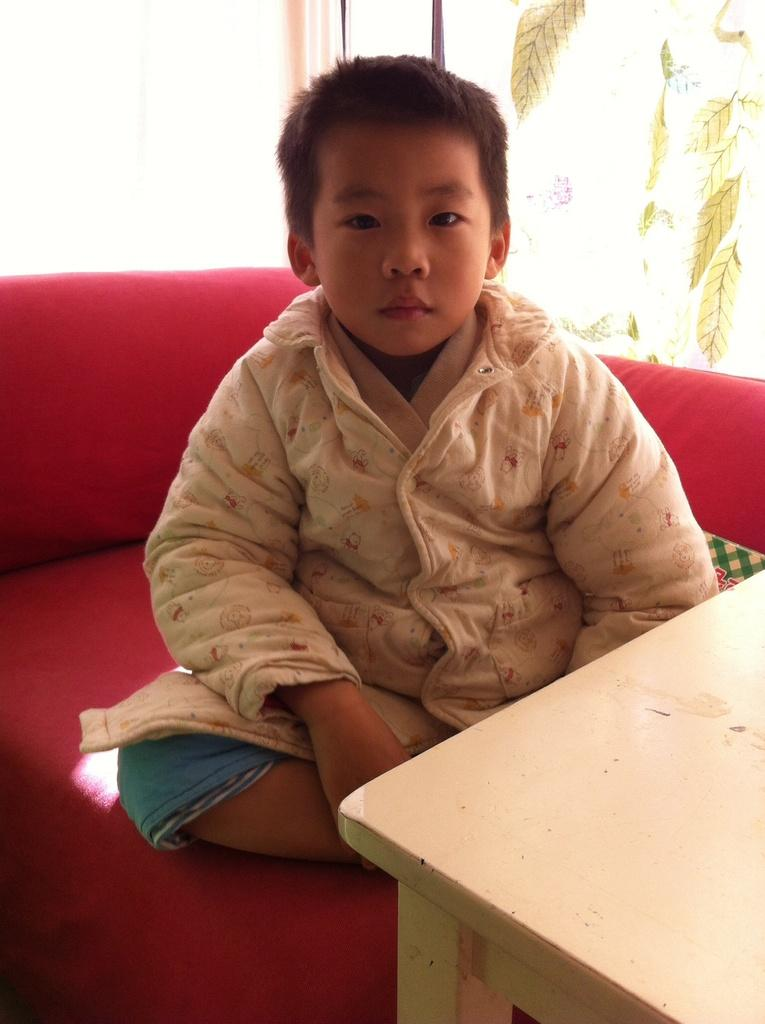Who is in the image? There is a boy in the image. What is the boy sitting on? The boy is sitting on a red sofa. What other furniture is present in the image? There is a table in the image. What can be seen in the background of the image? There is a window and a wall in the background of the image. What type of crate is being used as a footrest by the boy in the image? There is no crate present in the image; the boy is sitting on a red sofa. How many elbows does the boy have in the image? The boy has two elbows, but this question is not relevant to the image as it does not provide any useful information about the image. 